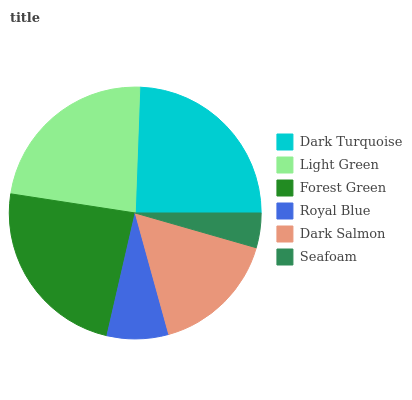Is Seafoam the minimum?
Answer yes or no. Yes. Is Dark Turquoise the maximum?
Answer yes or no. Yes. Is Light Green the minimum?
Answer yes or no. No. Is Light Green the maximum?
Answer yes or no. No. Is Dark Turquoise greater than Light Green?
Answer yes or no. Yes. Is Light Green less than Dark Turquoise?
Answer yes or no. Yes. Is Light Green greater than Dark Turquoise?
Answer yes or no. No. Is Dark Turquoise less than Light Green?
Answer yes or no. No. Is Light Green the high median?
Answer yes or no. Yes. Is Dark Salmon the low median?
Answer yes or no. Yes. Is Forest Green the high median?
Answer yes or no. No. Is Light Green the low median?
Answer yes or no. No. 